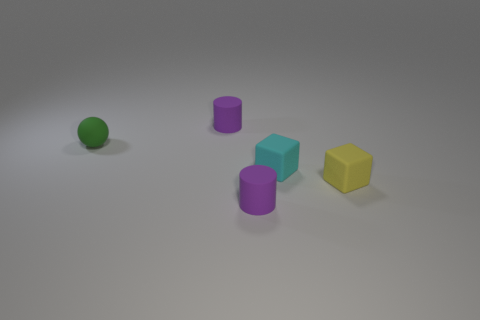How many rubber objects are either big gray things or small purple cylinders?
Keep it short and to the point. 2. The thing that is in front of the small cyan rubber block and to the left of the cyan block is made of what material?
Provide a short and direct response. Rubber. There is a matte cylinder that is in front of the purple cylinder behind the tiny yellow block; are there any small balls that are in front of it?
Your answer should be very brief. No. Are there any other things that are made of the same material as the cyan object?
Make the answer very short. Yes. There is a green object that is the same material as the small cyan block; what shape is it?
Your answer should be very brief. Sphere. Are there fewer cyan blocks that are to the left of the cyan matte object than tiny matte balls behind the rubber sphere?
Make the answer very short. No. How many small objects are either gray metallic objects or matte spheres?
Make the answer very short. 1. There is a small yellow matte thing that is on the right side of the tiny cyan cube; is it the same shape as the small purple rubber thing that is in front of the small cyan rubber thing?
Offer a terse response. No. How big is the cylinder on the left side of the small purple matte thing in front of the cylinder behind the yellow rubber block?
Ensure brevity in your answer.  Small. What is the size of the purple matte thing that is behind the tiny cyan cube?
Ensure brevity in your answer.  Small. 